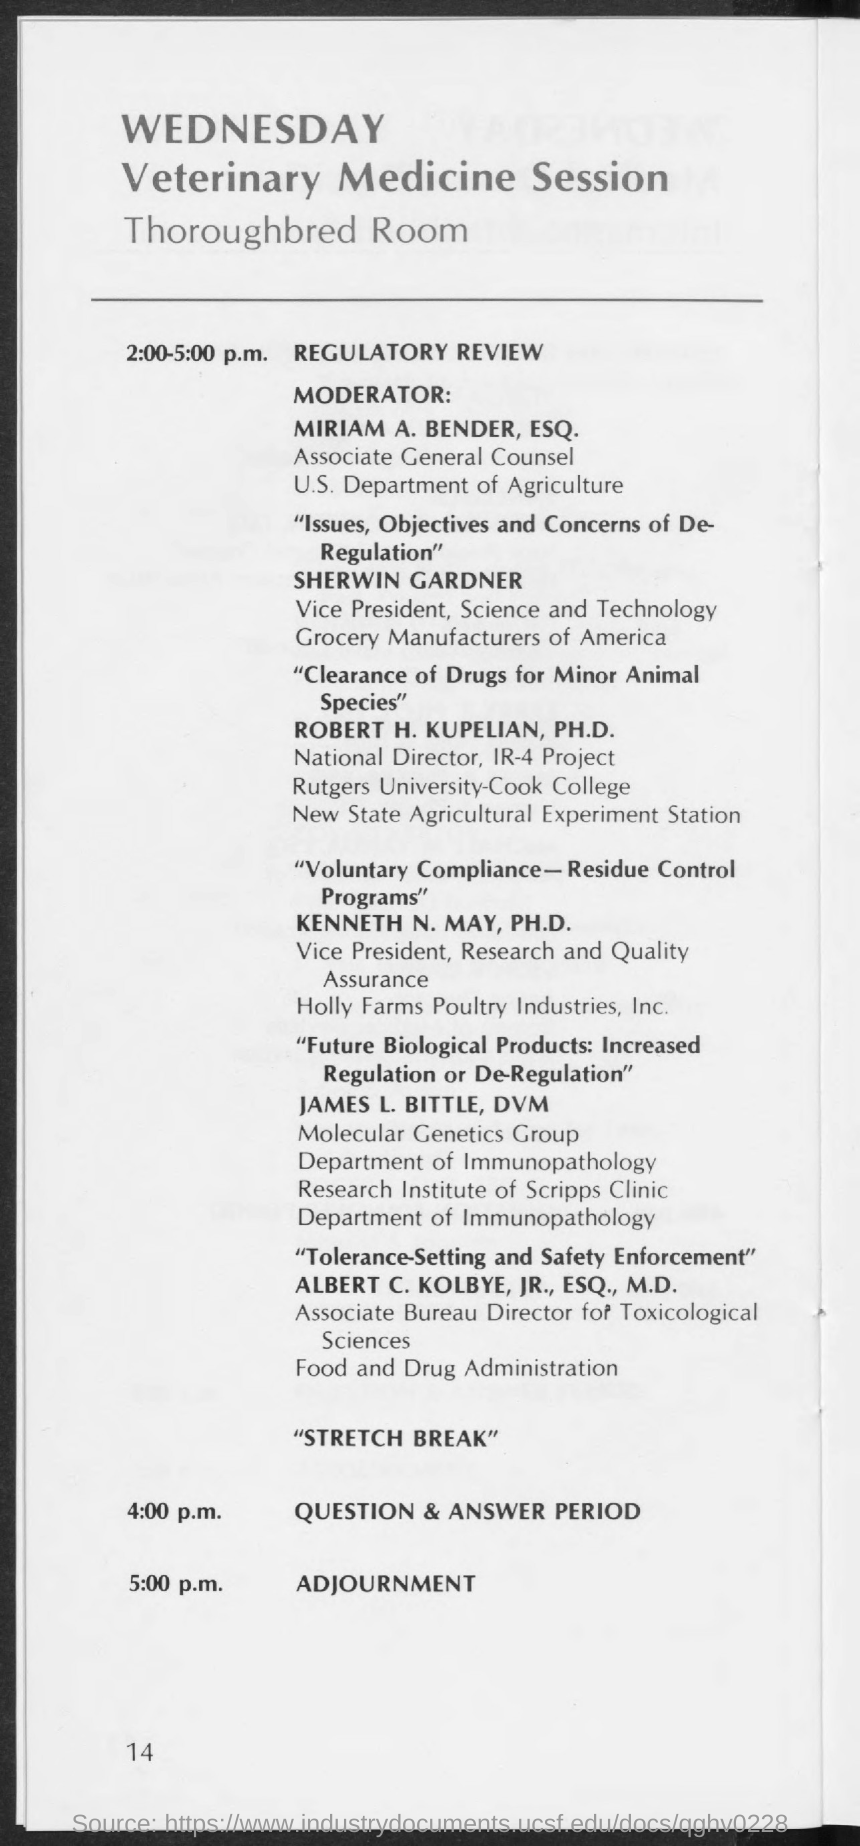When is the Regulatory Review?
Provide a short and direct response. 2:00-5:00 p.m. When is the Question & Answer Period?
Offer a very short reply. 4:00 p.m. 